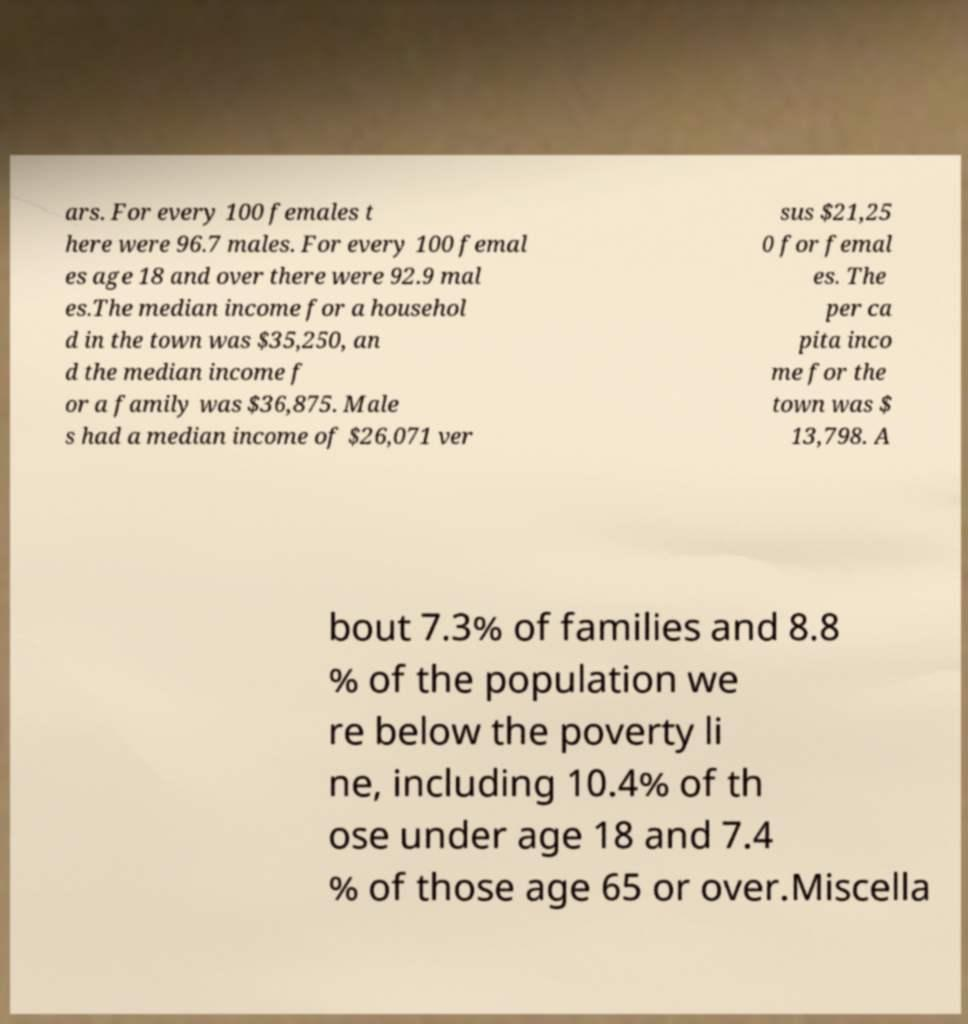Can you accurately transcribe the text from the provided image for me? ars. For every 100 females t here were 96.7 males. For every 100 femal es age 18 and over there were 92.9 mal es.The median income for a househol d in the town was $35,250, an d the median income f or a family was $36,875. Male s had a median income of $26,071 ver sus $21,25 0 for femal es. The per ca pita inco me for the town was $ 13,798. A bout 7.3% of families and 8.8 % of the population we re below the poverty li ne, including 10.4% of th ose under age 18 and 7.4 % of those age 65 or over.Miscella 